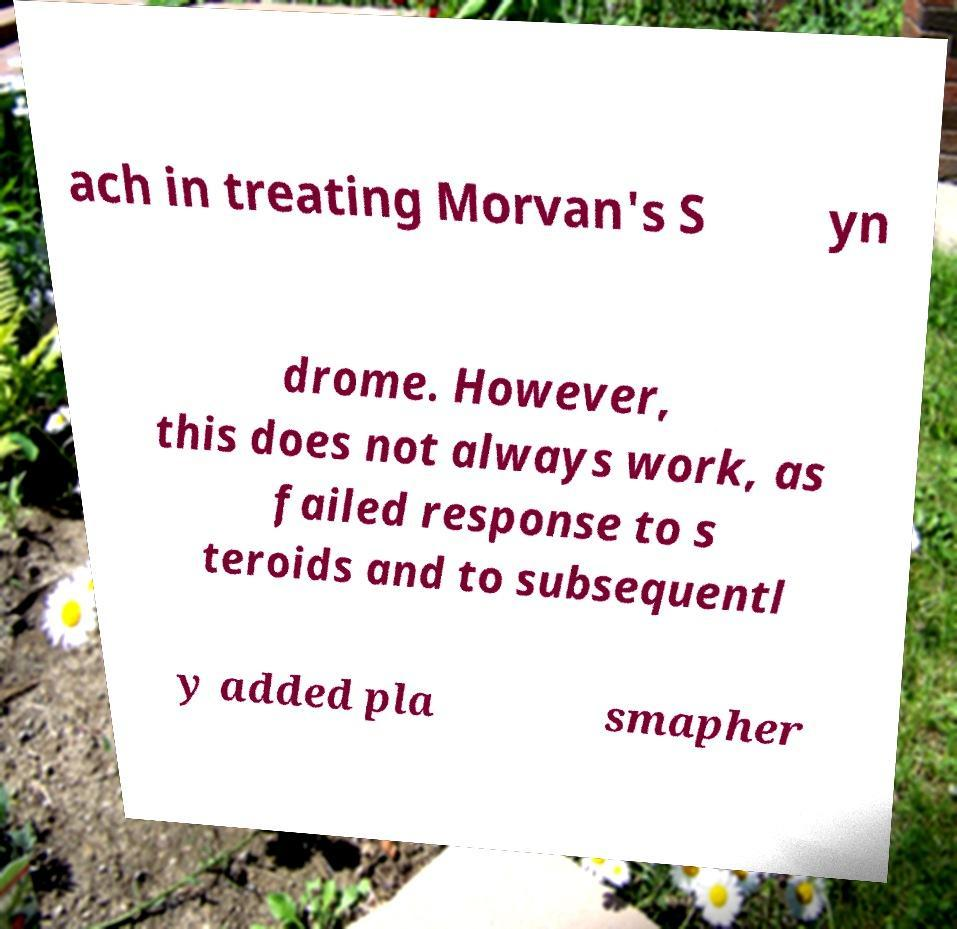There's text embedded in this image that I need extracted. Can you transcribe it verbatim? ach in treating Morvan's S yn drome. However, this does not always work, as failed response to s teroids and to subsequentl y added pla smapher 